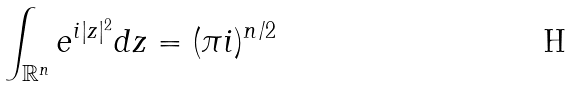Convert formula to latex. <formula><loc_0><loc_0><loc_500><loc_500>\int _ { \mathbb { R } ^ { n } } e ^ { i | z | ^ { 2 } } d z = ( \pi i ) ^ { n / 2 }</formula> 